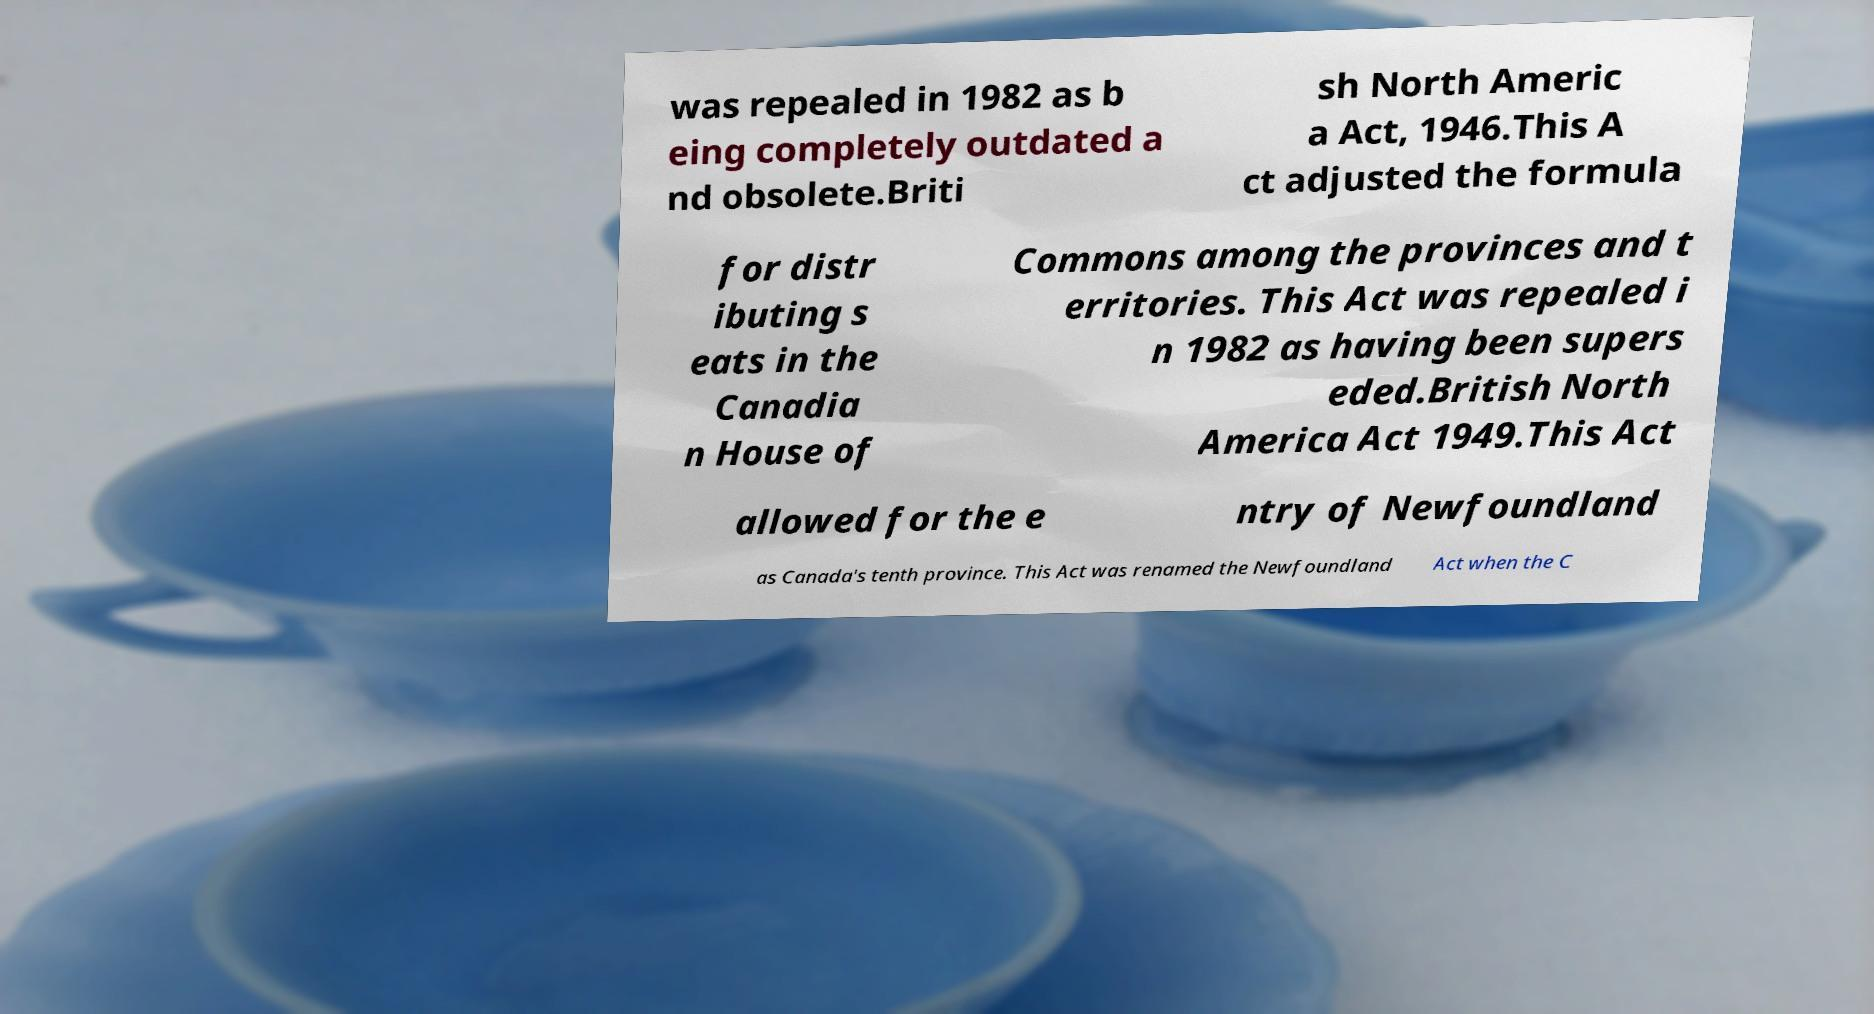For documentation purposes, I need the text within this image transcribed. Could you provide that? was repealed in 1982 as b eing completely outdated a nd obsolete.Briti sh North Americ a Act, 1946.This A ct adjusted the formula for distr ibuting s eats in the Canadia n House of Commons among the provinces and t erritories. This Act was repealed i n 1982 as having been supers eded.British North America Act 1949.This Act allowed for the e ntry of Newfoundland as Canada's tenth province. This Act was renamed the Newfoundland Act when the C 